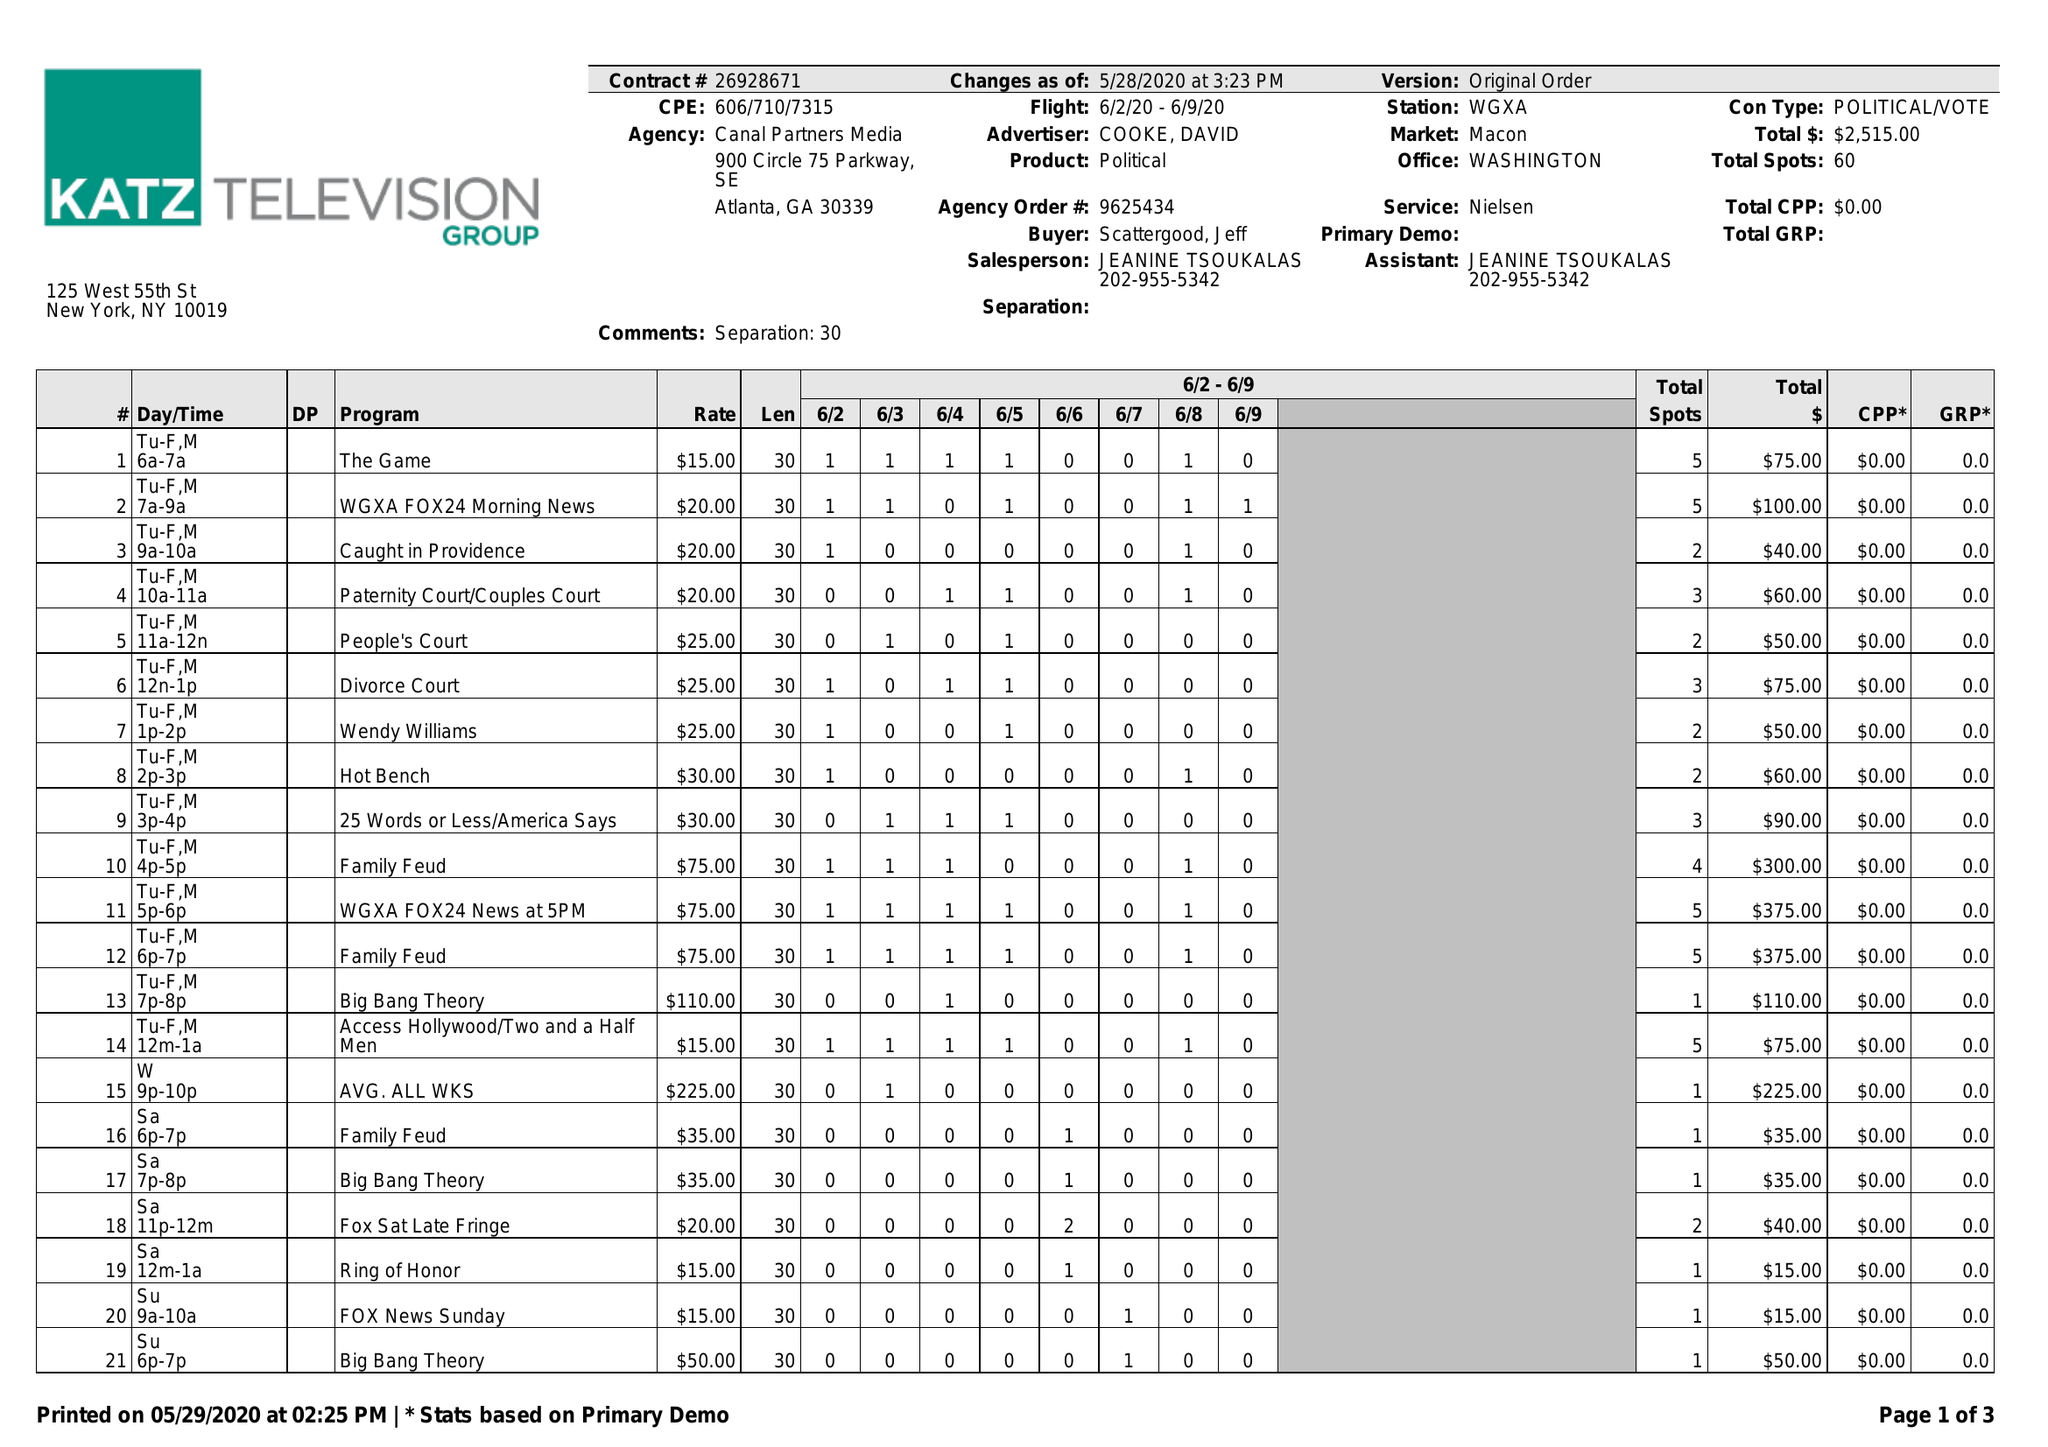What is the value for the flight_to?
Answer the question using a single word or phrase. 06/09/20 